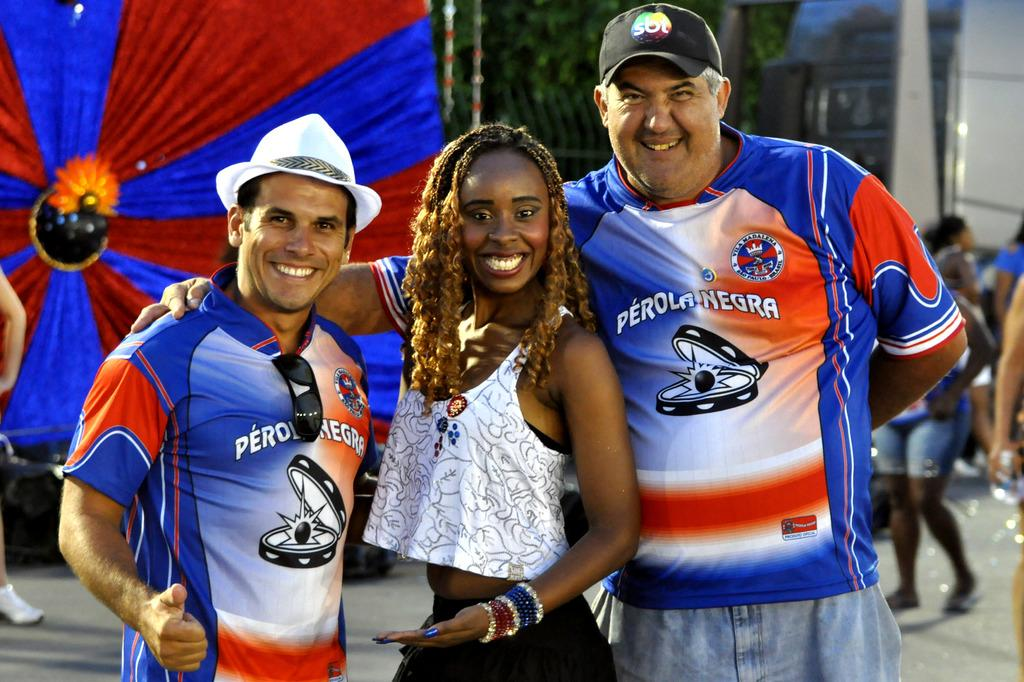<image>
Present a compact description of the photo's key features. three people smiling at the camera with PERONEGRA on the men's shirts, the woman is just in between them both. 